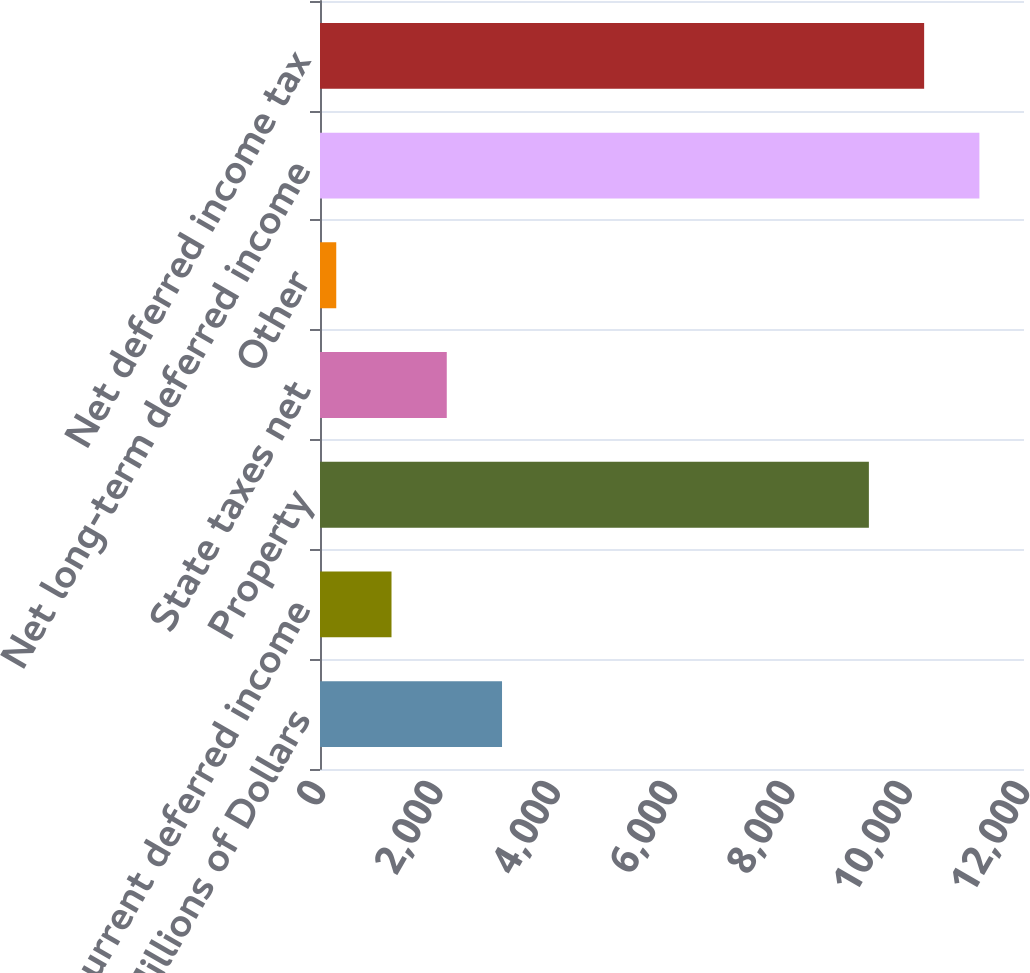<chart> <loc_0><loc_0><loc_500><loc_500><bar_chart><fcel>Millions of Dollars<fcel>Net current deferred income<fcel>Property<fcel>State taxes net<fcel>Other<fcel>Net long-term deferred income<fcel>Net deferred income tax<nl><fcel>3102.7<fcel>1218.9<fcel>9356<fcel>2160.8<fcel>277<fcel>11239.8<fcel>10297.9<nl></chart> 